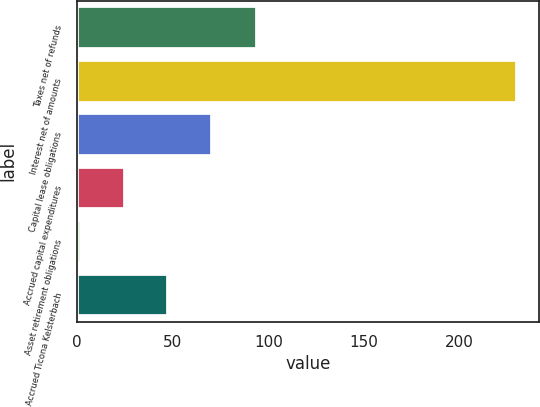<chart> <loc_0><loc_0><loc_500><loc_500><bar_chart><fcel>Taxes net of refunds<fcel>Interest net of amounts<fcel>Capital lease obligations<fcel>Accrued capital expenditures<fcel>Asset retirement obligations<fcel>Accrued Ticona Kelsterbach<nl><fcel>94<fcel>230<fcel>70.4<fcel>24.8<fcel>2<fcel>47.6<nl></chart> 